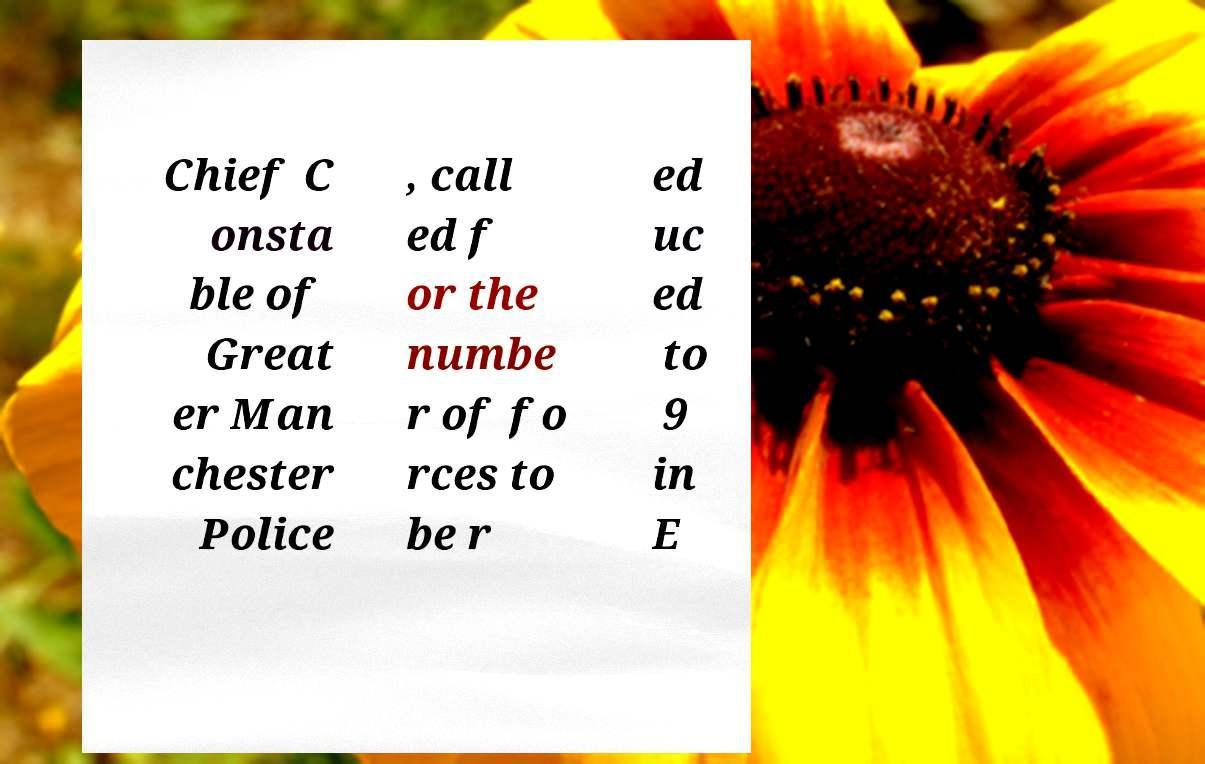Please read and relay the text visible in this image. What does it say? Chief C onsta ble of Great er Man chester Police , call ed f or the numbe r of fo rces to be r ed uc ed to 9 in E 